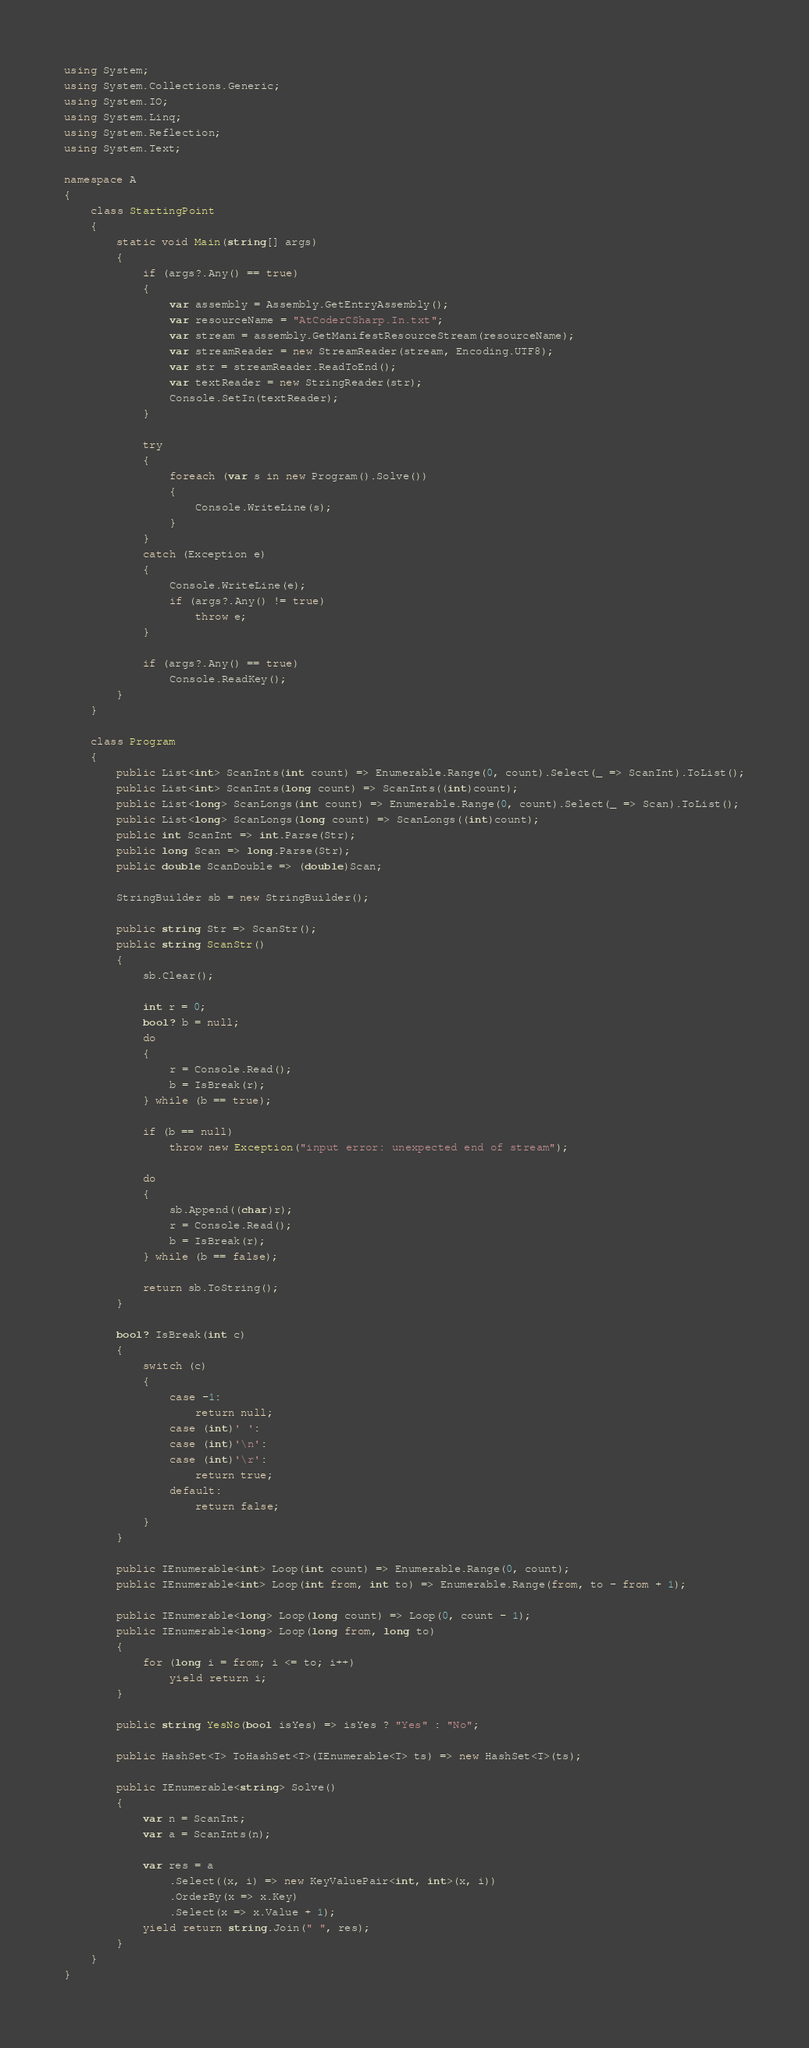Convert code to text. <code><loc_0><loc_0><loc_500><loc_500><_C#_>using System;
using System.Collections.Generic;
using System.IO;
using System.Linq;
using System.Reflection;
using System.Text;

namespace A
{
    class StartingPoint
    {
        static void Main(string[] args)
        {
            if (args?.Any() == true)
            {
                var assembly = Assembly.GetEntryAssembly();
                var resourceName = "AtCoderCSharp.In.txt";
                var stream = assembly.GetManifestResourceStream(resourceName);
                var streamReader = new StreamReader(stream, Encoding.UTF8);
                var str = streamReader.ReadToEnd();
                var textReader = new StringReader(str);
                Console.SetIn(textReader);
            }

            try
            {
                foreach (var s in new Program().Solve())
                {
                    Console.WriteLine(s);
                }
            }
            catch (Exception e)
            {
                Console.WriteLine(e);
                if (args?.Any() != true)
                    throw e;
            }

            if (args?.Any() == true)
                Console.ReadKey();
        }
    }

    class Program
    {
        public List<int> ScanInts(int count) => Enumerable.Range(0, count).Select(_ => ScanInt).ToList();
        public List<int> ScanInts(long count) => ScanInts((int)count);
        public List<long> ScanLongs(int count) => Enumerable.Range(0, count).Select(_ => Scan).ToList();
        public List<long> ScanLongs(long count) => ScanLongs((int)count);
        public int ScanInt => int.Parse(Str);
        public long Scan => long.Parse(Str);
        public double ScanDouble => (double)Scan;

        StringBuilder sb = new StringBuilder();

        public string Str => ScanStr();
        public string ScanStr()
        {
            sb.Clear();

            int r = 0;
            bool? b = null;
            do
            {
                r = Console.Read();
                b = IsBreak(r);
            } while (b == true);

            if (b == null)
                throw new Exception("input error: unexpected end of stream");

            do
            {
                sb.Append((char)r);
                r = Console.Read();
                b = IsBreak(r);
            } while (b == false);

            return sb.ToString();
        }

        bool? IsBreak(int c)
        {
            switch (c)
            {
                case -1:
                    return null;
                case (int)' ':
                case (int)'\n':
                case (int)'\r':
                    return true;
                default:
                    return false;
            }
        }

        public IEnumerable<int> Loop(int count) => Enumerable.Range(0, count);
        public IEnumerable<int> Loop(int from, int to) => Enumerable.Range(from, to - from + 1);

        public IEnumerable<long> Loop(long count) => Loop(0, count - 1);
        public IEnumerable<long> Loop(long from, long to)
        {
            for (long i = from; i <= to; i++)
                yield return i;
        }

        public string YesNo(bool isYes) => isYes ? "Yes" : "No";

        public HashSet<T> ToHashSet<T>(IEnumerable<T> ts) => new HashSet<T>(ts);

        public IEnumerable<string> Solve()
        {
            var n = ScanInt;
            var a = ScanInts(n);

            var res = a
                .Select((x, i) => new KeyValuePair<int, int>(x, i))
                .OrderBy(x => x.Key)
                .Select(x => x.Value + 1);
            yield return string.Join(" ", res);
        }
    }
}</code> 